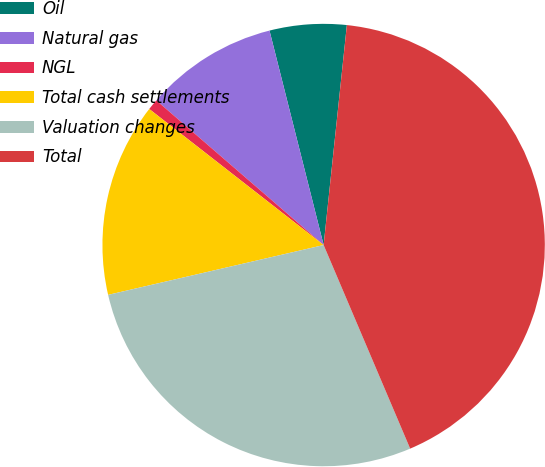<chart> <loc_0><loc_0><loc_500><loc_500><pie_chart><fcel>Oil<fcel>Natural gas<fcel>NGL<fcel>Total cash settlements<fcel>Valuation changes<fcel>Total<nl><fcel>5.61%<fcel>9.72%<fcel>0.8%<fcel>14.16%<fcel>27.78%<fcel>41.93%<nl></chart> 